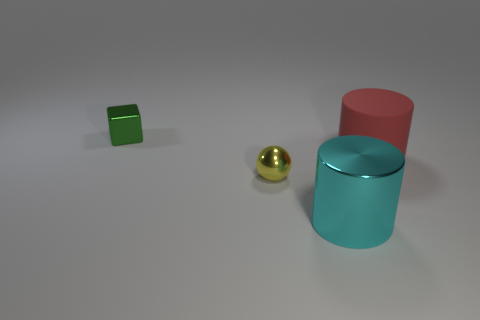Add 3 cyan metallic cylinders. How many objects exist? 7 Subtract all spheres. How many objects are left? 3 Add 4 shiny objects. How many shiny objects exist? 7 Subtract 1 cyan cylinders. How many objects are left? 3 Subtract all tiny things. Subtract all big cylinders. How many objects are left? 0 Add 2 large cyan metal cylinders. How many large cyan metal cylinders are left? 3 